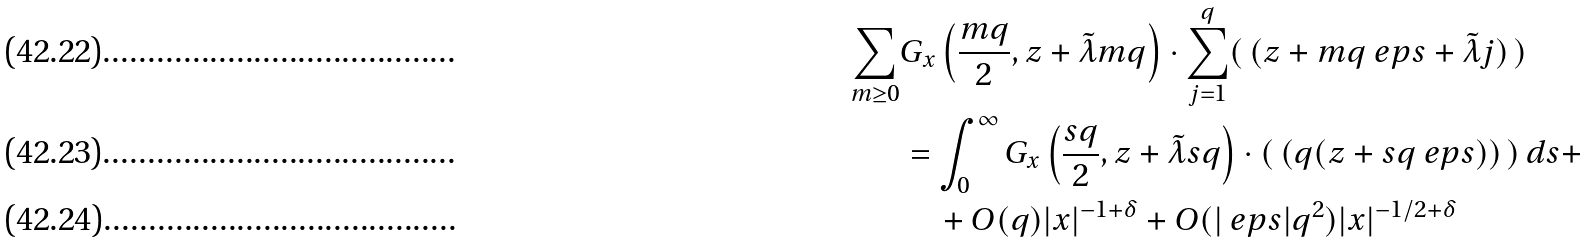Convert formula to latex. <formula><loc_0><loc_0><loc_500><loc_500>\sum _ { m \geq 0 } & G _ { x } \left ( \frac { m q } { 2 } , z + \tilde { \lambda } m q \right ) \cdot \sum _ { j = 1 } ^ { q } ( \, ( z + m q \ e p s + \tilde { \lambda } j ) \, ) \\ & = \int _ { 0 } ^ { \infty } G _ { x } \left ( \frac { s q } { 2 } , z + \tilde { \lambda } s q \right ) \cdot ( \, ( q ( z + s q \ e p s ) ) \, ) \, d s + \\ & \quad + O ( q ) | x | ^ { - 1 + \delta } + O ( | \ e p s | q ^ { 2 } ) | x | ^ { - 1 / 2 + \delta }</formula> 